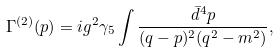Convert formula to latex. <formula><loc_0><loc_0><loc_500><loc_500>\Gamma ^ { ( 2 ) } ( p ) = i g ^ { 2 } \gamma _ { 5 } \int \frac { \bar { d } ^ { 4 } p } { ( q - p ) ^ { 2 } ( q ^ { 2 } - m ^ { 2 } ) } ,</formula> 